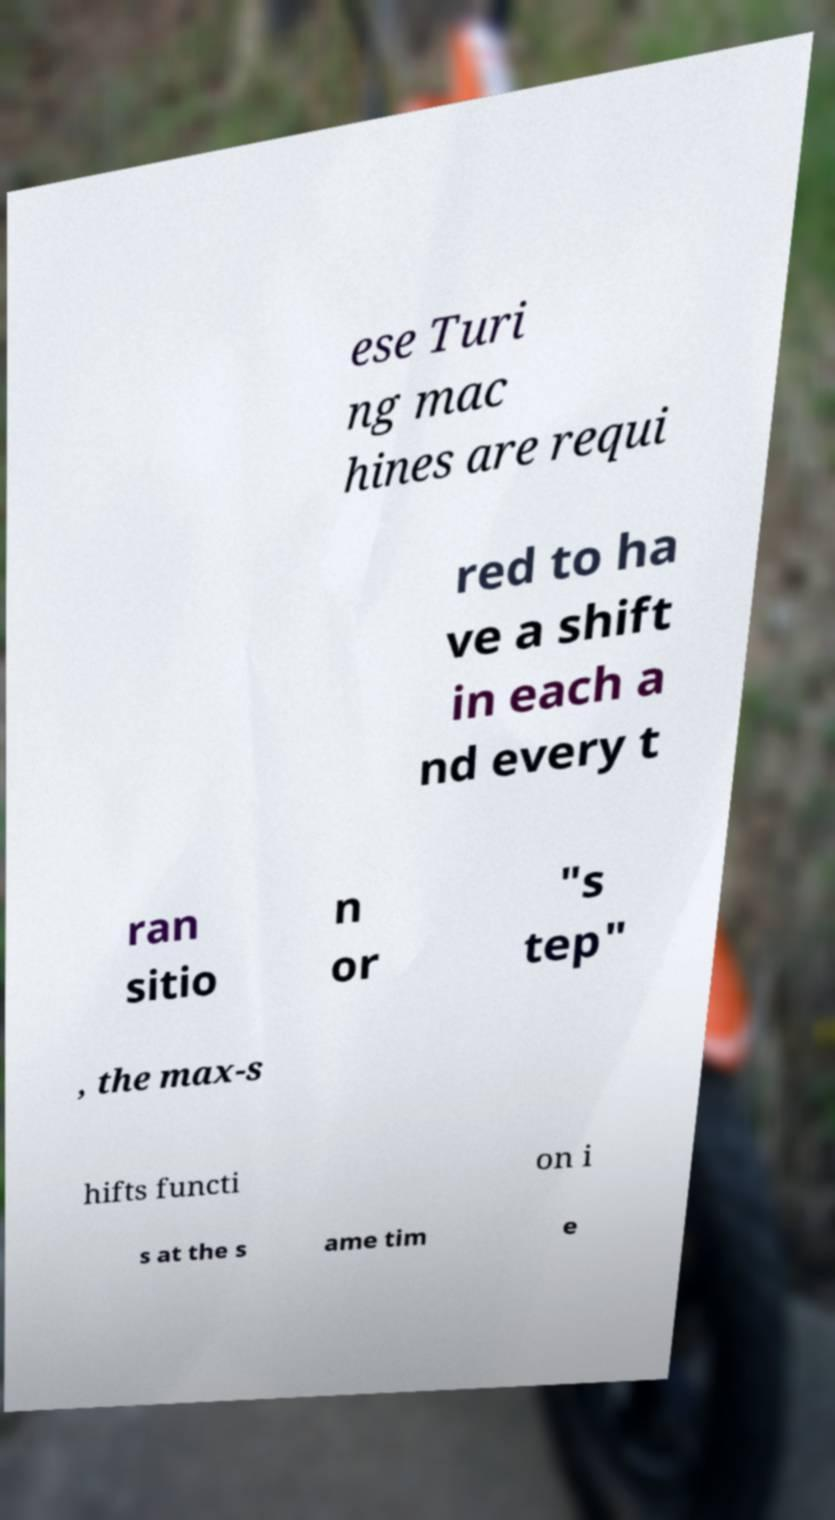There's text embedded in this image that I need extracted. Can you transcribe it verbatim? ese Turi ng mac hines are requi red to ha ve a shift in each a nd every t ran sitio n or "s tep" , the max-s hifts functi on i s at the s ame tim e 